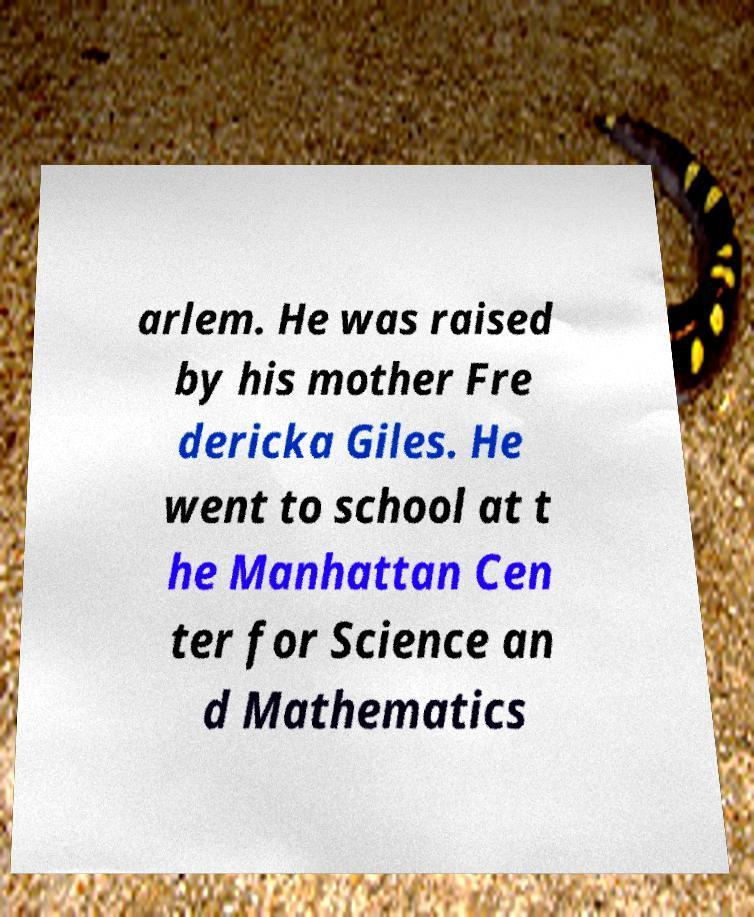There's text embedded in this image that I need extracted. Can you transcribe it verbatim? arlem. He was raised by his mother Fre dericka Giles. He went to school at t he Manhattan Cen ter for Science an d Mathematics 